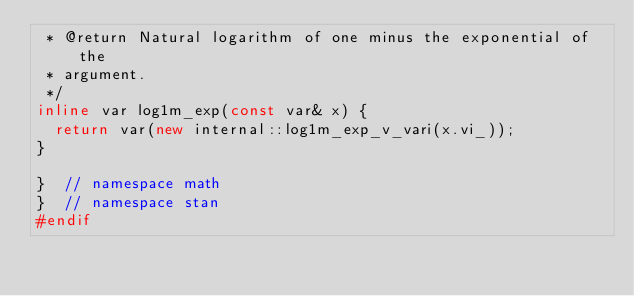<code> <loc_0><loc_0><loc_500><loc_500><_C++_> * @return Natural logarithm of one minus the exponential of the
 * argument.
 */
inline var log1m_exp(const var& x) {
  return var(new internal::log1m_exp_v_vari(x.vi_));
}

}  // namespace math
}  // namespace stan
#endif
</code> 